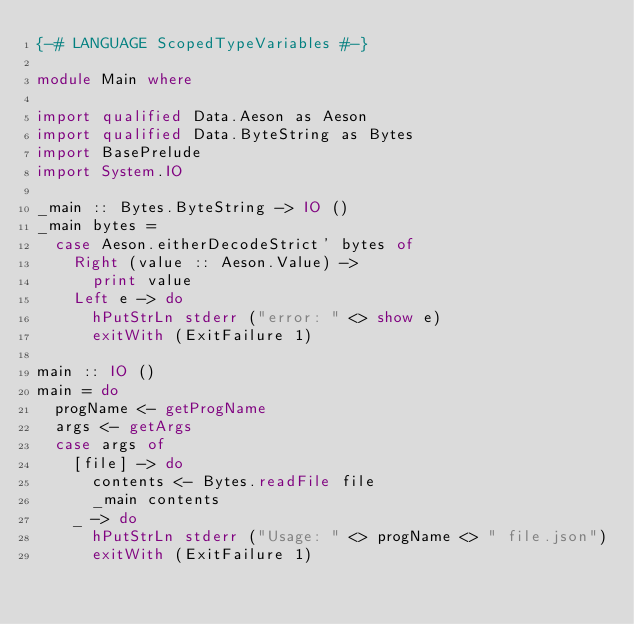Convert code to text. <code><loc_0><loc_0><loc_500><loc_500><_Haskell_>{-# LANGUAGE ScopedTypeVariables #-}

module Main where

import qualified Data.Aeson as Aeson
import qualified Data.ByteString as Bytes
import BasePrelude
import System.IO

_main :: Bytes.ByteString -> IO ()
_main bytes =
  case Aeson.eitherDecodeStrict' bytes of
    Right (value :: Aeson.Value) ->
      print value
    Left e -> do
      hPutStrLn stderr ("error: " <> show e)
      exitWith (ExitFailure 1)

main :: IO ()
main = do
  progName <- getProgName
  args <- getArgs
  case args of
    [file] -> do
      contents <- Bytes.readFile file
      _main contents
    _ -> do
      hPutStrLn stderr ("Usage: " <> progName <> " file.json")
      exitWith (ExitFailure 1)
</code> 